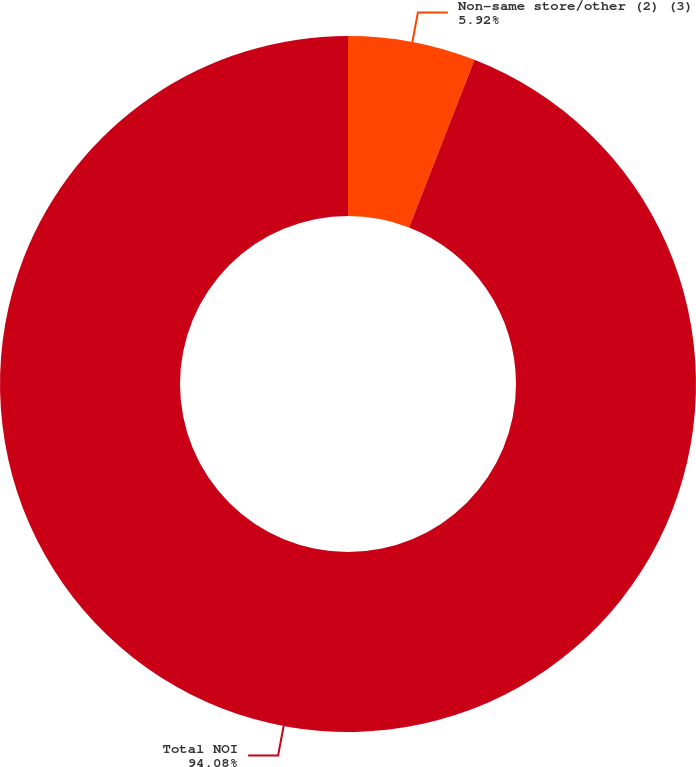<chart> <loc_0><loc_0><loc_500><loc_500><pie_chart><fcel>Non-same store/other (2) (3)<fcel>Total NOI<nl><fcel>5.92%<fcel>94.08%<nl></chart> 